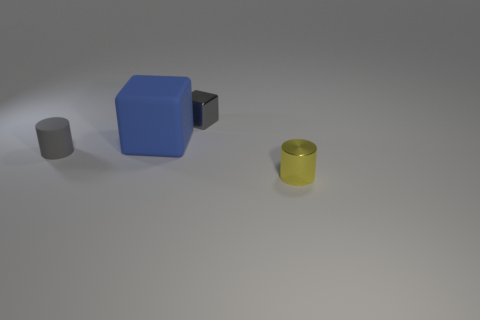Add 3 tiny shiny cylinders. How many objects exist? 7 Add 1 gray metal cylinders. How many gray metal cylinders exist? 1 Subtract 0 purple cylinders. How many objects are left? 4 Subtract all tiny brown cubes. Subtract all big blue rubber things. How many objects are left? 3 Add 2 small yellow metal objects. How many small yellow metal objects are left? 3 